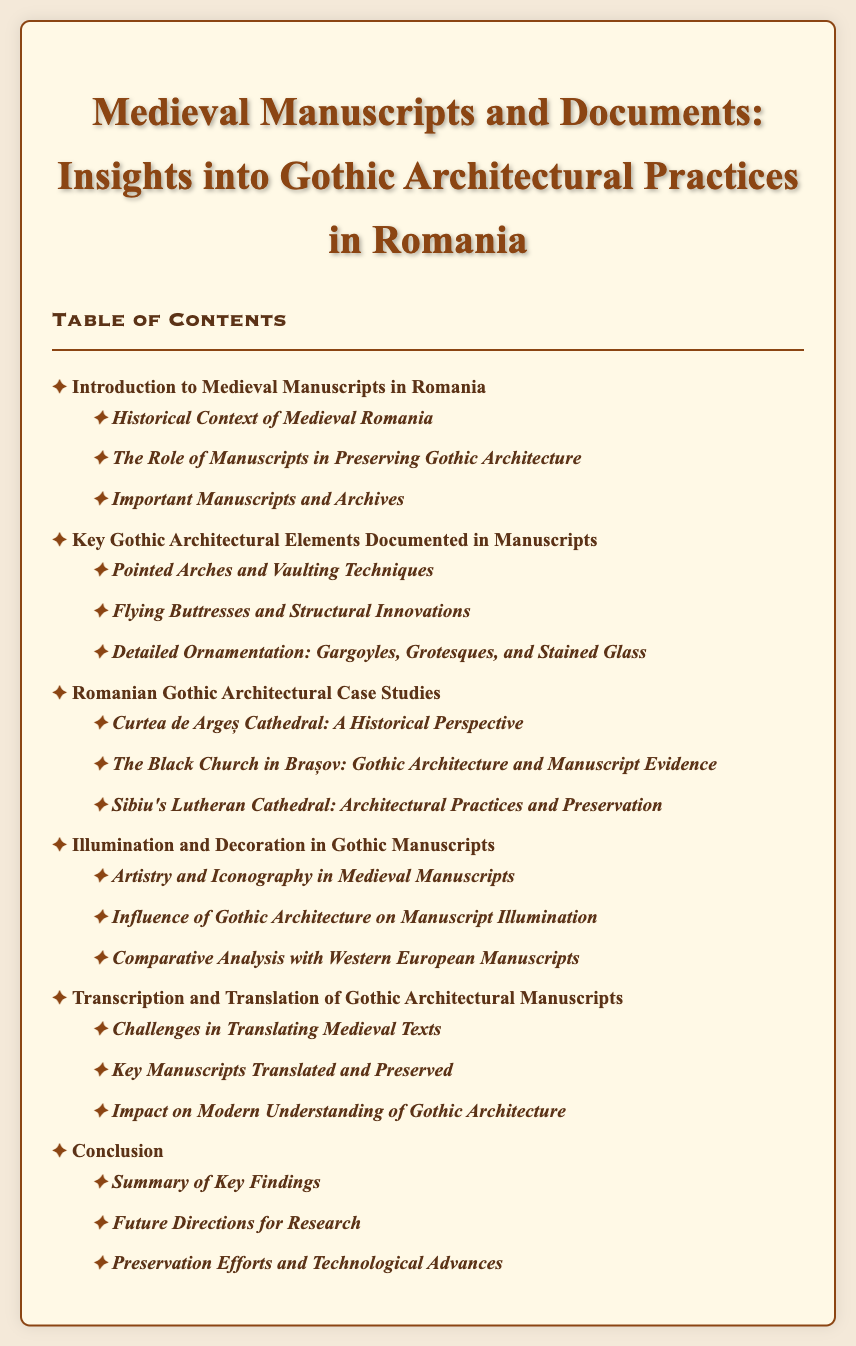What is the title of the document? The title of the document is presented prominently at the top, indicating the focus of the content.
Answer: Medieval Manuscripts and Documents: Insights into Gothic Architectural Practices in Romania How many chapters are listed in the Table of Contents? The number of chapters is determined by counting all main chapter headings in the document.
Answer: Six What is the first sub-section under the introduction? The first sub-section is the first item listed under the "Introduction to Medieval Manuscripts in Romania."
Answer: Historical Context of Medieval Romania Which cathedral is mentioned in the Romanian Gothic Architectural Case Studies? The document includes specific case studies, one of which is a notable cathedral.
Answer: Curtea de Argeș Cathedral What is the last section listed in the conclusion chapter? The last section is found under the final chapter heading, summarizing its contents.
Answer: Preservation Efforts and Technological Advances What element of Gothic architecture is discussed in the second chapter? This chapter focuses on specific elements associated with Gothic architecture as documented in manuscripts.
Answer: Pointed Arches and Vaulting Techniques How is the decoration in Gothic manuscripts described? This section addresses artistic aspects of Gothic manuscripts, detailing their creative elements.
Answer: Artistry and Iconography in Medieval Manuscripts 